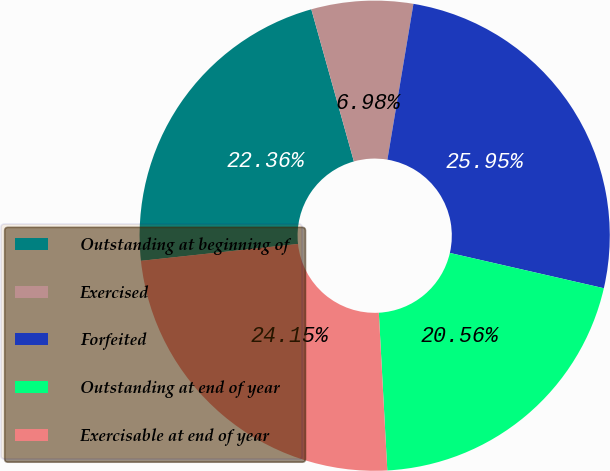Convert chart to OTSL. <chart><loc_0><loc_0><loc_500><loc_500><pie_chart><fcel>Outstanding at beginning of<fcel>Exercised<fcel>Forfeited<fcel>Outstanding at end of year<fcel>Exercisable at end of year<nl><fcel>22.36%<fcel>6.98%<fcel>25.95%<fcel>20.56%<fcel>24.15%<nl></chart> 